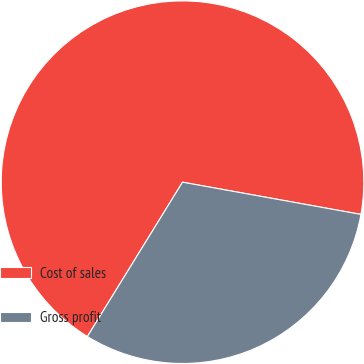Convert chart. <chart><loc_0><loc_0><loc_500><loc_500><pie_chart><fcel>Cost of sales<fcel>Gross profit<nl><fcel>69.05%<fcel>30.95%<nl></chart> 